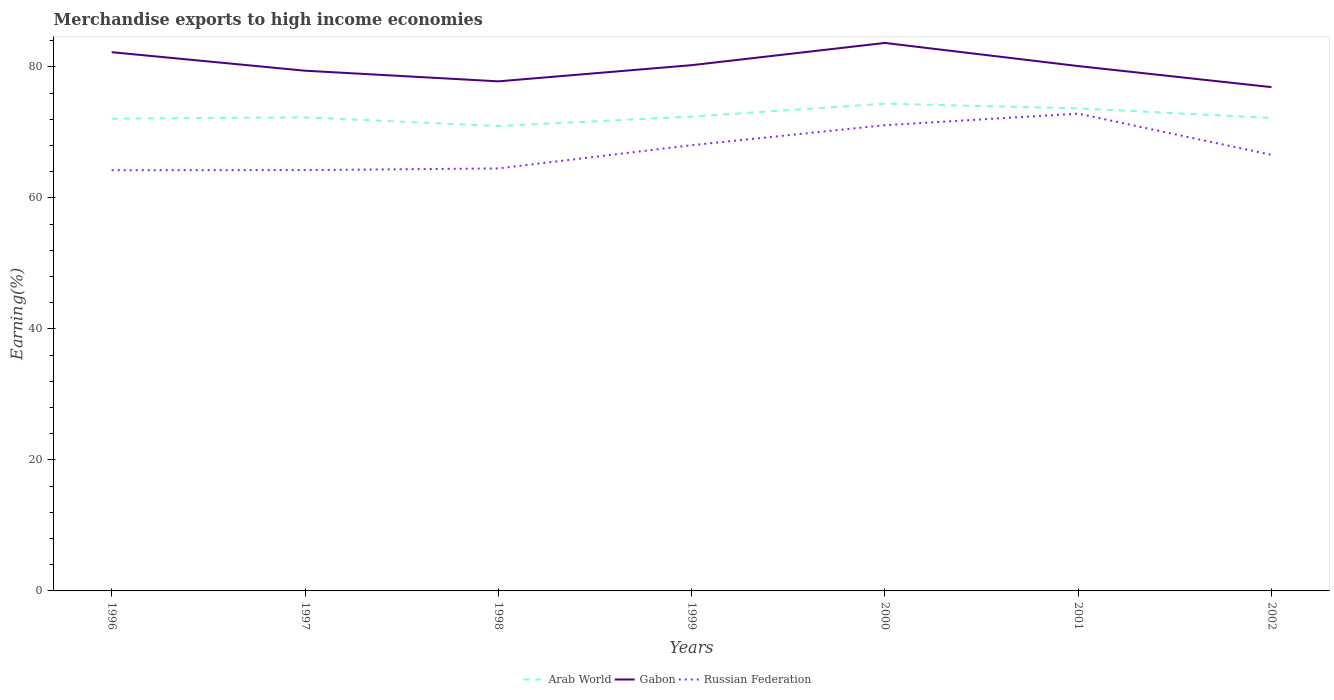How many different coloured lines are there?
Keep it short and to the point. 3. Does the line corresponding to Arab World intersect with the line corresponding to Gabon?
Provide a succinct answer. No. Across all years, what is the maximum percentage of amount earned from merchandise exports in Arab World?
Make the answer very short. 70.98. What is the total percentage of amount earned from merchandise exports in Russian Federation in the graph?
Your answer should be very brief. -3.55. What is the difference between the highest and the second highest percentage of amount earned from merchandise exports in Gabon?
Provide a succinct answer. 6.75. How many years are there in the graph?
Make the answer very short. 7. What is the difference between two consecutive major ticks on the Y-axis?
Ensure brevity in your answer.  20. Are the values on the major ticks of Y-axis written in scientific E-notation?
Make the answer very short. No. How many legend labels are there?
Ensure brevity in your answer.  3. How are the legend labels stacked?
Your answer should be very brief. Horizontal. What is the title of the graph?
Offer a terse response. Merchandise exports to high income economies. What is the label or title of the Y-axis?
Offer a terse response. Earning(%). What is the Earning(%) in Arab World in 1996?
Your answer should be very brief. 72.1. What is the Earning(%) of Gabon in 1996?
Your response must be concise. 82.25. What is the Earning(%) in Russian Federation in 1996?
Provide a succinct answer. 64.23. What is the Earning(%) in Arab World in 1997?
Your answer should be very brief. 72.3. What is the Earning(%) of Gabon in 1997?
Offer a very short reply. 79.42. What is the Earning(%) in Russian Federation in 1997?
Provide a short and direct response. 64.25. What is the Earning(%) of Arab World in 1998?
Provide a short and direct response. 70.98. What is the Earning(%) in Gabon in 1998?
Keep it short and to the point. 77.8. What is the Earning(%) in Russian Federation in 1998?
Offer a terse response. 64.5. What is the Earning(%) of Arab World in 1999?
Provide a short and direct response. 72.42. What is the Earning(%) in Gabon in 1999?
Offer a terse response. 80.27. What is the Earning(%) in Russian Federation in 1999?
Provide a succinct answer. 68.05. What is the Earning(%) in Arab World in 2000?
Keep it short and to the point. 74.39. What is the Earning(%) of Gabon in 2000?
Keep it short and to the point. 83.66. What is the Earning(%) of Russian Federation in 2000?
Keep it short and to the point. 71.11. What is the Earning(%) of Arab World in 2001?
Provide a succinct answer. 73.68. What is the Earning(%) in Gabon in 2001?
Give a very brief answer. 80.13. What is the Earning(%) in Russian Federation in 2001?
Ensure brevity in your answer.  72.87. What is the Earning(%) of Arab World in 2002?
Provide a short and direct response. 72.21. What is the Earning(%) of Gabon in 2002?
Give a very brief answer. 76.92. What is the Earning(%) of Russian Federation in 2002?
Offer a terse response. 66.58. Across all years, what is the maximum Earning(%) in Arab World?
Give a very brief answer. 74.39. Across all years, what is the maximum Earning(%) of Gabon?
Your answer should be compact. 83.66. Across all years, what is the maximum Earning(%) of Russian Federation?
Ensure brevity in your answer.  72.87. Across all years, what is the minimum Earning(%) of Arab World?
Make the answer very short. 70.98. Across all years, what is the minimum Earning(%) of Gabon?
Make the answer very short. 76.92. Across all years, what is the minimum Earning(%) of Russian Federation?
Provide a succinct answer. 64.23. What is the total Earning(%) of Arab World in the graph?
Your answer should be compact. 508.08. What is the total Earning(%) of Gabon in the graph?
Make the answer very short. 560.46. What is the total Earning(%) of Russian Federation in the graph?
Give a very brief answer. 471.6. What is the difference between the Earning(%) of Arab World in 1996 and that in 1997?
Provide a short and direct response. -0.2. What is the difference between the Earning(%) in Gabon in 1996 and that in 1997?
Your response must be concise. 2.83. What is the difference between the Earning(%) in Russian Federation in 1996 and that in 1997?
Offer a very short reply. -0.02. What is the difference between the Earning(%) of Arab World in 1996 and that in 1998?
Keep it short and to the point. 1.12. What is the difference between the Earning(%) in Gabon in 1996 and that in 1998?
Keep it short and to the point. 4.45. What is the difference between the Earning(%) of Russian Federation in 1996 and that in 1998?
Offer a terse response. -0.27. What is the difference between the Earning(%) of Arab World in 1996 and that in 1999?
Provide a succinct answer. -0.32. What is the difference between the Earning(%) of Gabon in 1996 and that in 1999?
Provide a succinct answer. 1.98. What is the difference between the Earning(%) in Russian Federation in 1996 and that in 1999?
Give a very brief answer. -3.82. What is the difference between the Earning(%) of Arab World in 1996 and that in 2000?
Keep it short and to the point. -2.29. What is the difference between the Earning(%) in Gabon in 1996 and that in 2000?
Ensure brevity in your answer.  -1.41. What is the difference between the Earning(%) in Russian Federation in 1996 and that in 2000?
Offer a very short reply. -6.87. What is the difference between the Earning(%) of Arab World in 1996 and that in 2001?
Your response must be concise. -1.57. What is the difference between the Earning(%) in Gabon in 1996 and that in 2001?
Give a very brief answer. 2.12. What is the difference between the Earning(%) of Russian Federation in 1996 and that in 2001?
Give a very brief answer. -8.64. What is the difference between the Earning(%) in Arab World in 1996 and that in 2002?
Your answer should be very brief. -0.11. What is the difference between the Earning(%) of Gabon in 1996 and that in 2002?
Give a very brief answer. 5.33. What is the difference between the Earning(%) of Russian Federation in 1996 and that in 2002?
Ensure brevity in your answer.  -2.34. What is the difference between the Earning(%) of Arab World in 1997 and that in 1998?
Your answer should be very brief. 1.32. What is the difference between the Earning(%) of Gabon in 1997 and that in 1998?
Provide a succinct answer. 1.62. What is the difference between the Earning(%) of Russian Federation in 1997 and that in 1998?
Make the answer very short. -0.25. What is the difference between the Earning(%) of Arab World in 1997 and that in 1999?
Offer a very short reply. -0.12. What is the difference between the Earning(%) in Gabon in 1997 and that in 1999?
Your answer should be compact. -0.84. What is the difference between the Earning(%) of Russian Federation in 1997 and that in 1999?
Ensure brevity in your answer.  -3.8. What is the difference between the Earning(%) of Arab World in 1997 and that in 2000?
Offer a terse response. -2.09. What is the difference between the Earning(%) in Gabon in 1997 and that in 2000?
Your answer should be very brief. -4.24. What is the difference between the Earning(%) in Russian Federation in 1997 and that in 2000?
Give a very brief answer. -6.86. What is the difference between the Earning(%) of Arab World in 1997 and that in 2001?
Make the answer very short. -1.38. What is the difference between the Earning(%) of Gabon in 1997 and that in 2001?
Offer a terse response. -0.71. What is the difference between the Earning(%) in Russian Federation in 1997 and that in 2001?
Your answer should be very brief. -8.62. What is the difference between the Earning(%) of Arab World in 1997 and that in 2002?
Ensure brevity in your answer.  0.09. What is the difference between the Earning(%) of Gabon in 1997 and that in 2002?
Make the answer very short. 2.51. What is the difference between the Earning(%) in Russian Federation in 1997 and that in 2002?
Your answer should be compact. -2.33. What is the difference between the Earning(%) of Arab World in 1998 and that in 1999?
Ensure brevity in your answer.  -1.44. What is the difference between the Earning(%) in Gabon in 1998 and that in 1999?
Ensure brevity in your answer.  -2.47. What is the difference between the Earning(%) of Russian Federation in 1998 and that in 1999?
Your answer should be very brief. -3.55. What is the difference between the Earning(%) of Arab World in 1998 and that in 2000?
Give a very brief answer. -3.41. What is the difference between the Earning(%) of Gabon in 1998 and that in 2000?
Offer a terse response. -5.86. What is the difference between the Earning(%) of Russian Federation in 1998 and that in 2000?
Give a very brief answer. -6.6. What is the difference between the Earning(%) in Arab World in 1998 and that in 2001?
Offer a terse response. -2.69. What is the difference between the Earning(%) of Gabon in 1998 and that in 2001?
Ensure brevity in your answer.  -2.33. What is the difference between the Earning(%) in Russian Federation in 1998 and that in 2001?
Offer a very short reply. -8.37. What is the difference between the Earning(%) of Arab World in 1998 and that in 2002?
Your answer should be compact. -1.23. What is the difference between the Earning(%) of Gabon in 1998 and that in 2002?
Your answer should be compact. 0.88. What is the difference between the Earning(%) in Russian Federation in 1998 and that in 2002?
Ensure brevity in your answer.  -2.07. What is the difference between the Earning(%) in Arab World in 1999 and that in 2000?
Give a very brief answer. -1.97. What is the difference between the Earning(%) of Gabon in 1999 and that in 2000?
Your answer should be very brief. -3.39. What is the difference between the Earning(%) of Russian Federation in 1999 and that in 2000?
Give a very brief answer. -3.05. What is the difference between the Earning(%) of Arab World in 1999 and that in 2001?
Ensure brevity in your answer.  -1.26. What is the difference between the Earning(%) of Gabon in 1999 and that in 2001?
Ensure brevity in your answer.  0.14. What is the difference between the Earning(%) in Russian Federation in 1999 and that in 2001?
Give a very brief answer. -4.82. What is the difference between the Earning(%) in Arab World in 1999 and that in 2002?
Provide a succinct answer. 0.21. What is the difference between the Earning(%) of Gabon in 1999 and that in 2002?
Provide a short and direct response. 3.35. What is the difference between the Earning(%) of Russian Federation in 1999 and that in 2002?
Ensure brevity in your answer.  1.48. What is the difference between the Earning(%) of Arab World in 2000 and that in 2001?
Provide a short and direct response. 0.72. What is the difference between the Earning(%) in Gabon in 2000 and that in 2001?
Offer a terse response. 3.53. What is the difference between the Earning(%) in Russian Federation in 2000 and that in 2001?
Make the answer very short. -1.76. What is the difference between the Earning(%) in Arab World in 2000 and that in 2002?
Your response must be concise. 2.18. What is the difference between the Earning(%) of Gabon in 2000 and that in 2002?
Keep it short and to the point. 6.75. What is the difference between the Earning(%) in Russian Federation in 2000 and that in 2002?
Offer a terse response. 4.53. What is the difference between the Earning(%) of Arab World in 2001 and that in 2002?
Make the answer very short. 1.47. What is the difference between the Earning(%) in Gabon in 2001 and that in 2002?
Offer a terse response. 3.22. What is the difference between the Earning(%) of Russian Federation in 2001 and that in 2002?
Your answer should be compact. 6.29. What is the difference between the Earning(%) in Arab World in 1996 and the Earning(%) in Gabon in 1997?
Offer a very short reply. -7.32. What is the difference between the Earning(%) in Arab World in 1996 and the Earning(%) in Russian Federation in 1997?
Offer a very short reply. 7.85. What is the difference between the Earning(%) in Gabon in 1996 and the Earning(%) in Russian Federation in 1997?
Give a very brief answer. 18. What is the difference between the Earning(%) of Arab World in 1996 and the Earning(%) of Gabon in 1998?
Your answer should be compact. -5.7. What is the difference between the Earning(%) in Arab World in 1996 and the Earning(%) in Russian Federation in 1998?
Make the answer very short. 7.6. What is the difference between the Earning(%) in Gabon in 1996 and the Earning(%) in Russian Federation in 1998?
Your response must be concise. 17.75. What is the difference between the Earning(%) in Arab World in 1996 and the Earning(%) in Gabon in 1999?
Offer a very short reply. -8.17. What is the difference between the Earning(%) in Arab World in 1996 and the Earning(%) in Russian Federation in 1999?
Ensure brevity in your answer.  4.05. What is the difference between the Earning(%) of Gabon in 1996 and the Earning(%) of Russian Federation in 1999?
Your answer should be very brief. 14.2. What is the difference between the Earning(%) of Arab World in 1996 and the Earning(%) of Gabon in 2000?
Make the answer very short. -11.56. What is the difference between the Earning(%) of Arab World in 1996 and the Earning(%) of Russian Federation in 2000?
Your response must be concise. 1. What is the difference between the Earning(%) of Gabon in 1996 and the Earning(%) of Russian Federation in 2000?
Give a very brief answer. 11.14. What is the difference between the Earning(%) of Arab World in 1996 and the Earning(%) of Gabon in 2001?
Make the answer very short. -8.03. What is the difference between the Earning(%) in Arab World in 1996 and the Earning(%) in Russian Federation in 2001?
Keep it short and to the point. -0.77. What is the difference between the Earning(%) in Gabon in 1996 and the Earning(%) in Russian Federation in 2001?
Your response must be concise. 9.38. What is the difference between the Earning(%) in Arab World in 1996 and the Earning(%) in Gabon in 2002?
Provide a short and direct response. -4.81. What is the difference between the Earning(%) of Arab World in 1996 and the Earning(%) of Russian Federation in 2002?
Offer a very short reply. 5.53. What is the difference between the Earning(%) in Gabon in 1996 and the Earning(%) in Russian Federation in 2002?
Make the answer very short. 15.67. What is the difference between the Earning(%) of Arab World in 1997 and the Earning(%) of Gabon in 1998?
Make the answer very short. -5.5. What is the difference between the Earning(%) of Arab World in 1997 and the Earning(%) of Russian Federation in 1998?
Your response must be concise. 7.8. What is the difference between the Earning(%) in Gabon in 1997 and the Earning(%) in Russian Federation in 1998?
Give a very brief answer. 14.92. What is the difference between the Earning(%) of Arab World in 1997 and the Earning(%) of Gabon in 1999?
Give a very brief answer. -7.97. What is the difference between the Earning(%) of Arab World in 1997 and the Earning(%) of Russian Federation in 1999?
Provide a succinct answer. 4.25. What is the difference between the Earning(%) of Gabon in 1997 and the Earning(%) of Russian Federation in 1999?
Make the answer very short. 11.37. What is the difference between the Earning(%) of Arab World in 1997 and the Earning(%) of Gabon in 2000?
Your answer should be compact. -11.36. What is the difference between the Earning(%) in Arab World in 1997 and the Earning(%) in Russian Federation in 2000?
Give a very brief answer. 1.19. What is the difference between the Earning(%) of Gabon in 1997 and the Earning(%) of Russian Federation in 2000?
Your answer should be compact. 8.32. What is the difference between the Earning(%) of Arab World in 1997 and the Earning(%) of Gabon in 2001?
Provide a short and direct response. -7.83. What is the difference between the Earning(%) in Arab World in 1997 and the Earning(%) in Russian Federation in 2001?
Provide a short and direct response. -0.57. What is the difference between the Earning(%) in Gabon in 1997 and the Earning(%) in Russian Federation in 2001?
Your response must be concise. 6.55. What is the difference between the Earning(%) in Arab World in 1997 and the Earning(%) in Gabon in 2002?
Keep it short and to the point. -4.62. What is the difference between the Earning(%) in Arab World in 1997 and the Earning(%) in Russian Federation in 2002?
Your answer should be compact. 5.72. What is the difference between the Earning(%) of Gabon in 1997 and the Earning(%) of Russian Federation in 2002?
Offer a terse response. 12.85. What is the difference between the Earning(%) in Arab World in 1998 and the Earning(%) in Gabon in 1999?
Ensure brevity in your answer.  -9.29. What is the difference between the Earning(%) in Arab World in 1998 and the Earning(%) in Russian Federation in 1999?
Provide a short and direct response. 2.93. What is the difference between the Earning(%) in Gabon in 1998 and the Earning(%) in Russian Federation in 1999?
Ensure brevity in your answer.  9.75. What is the difference between the Earning(%) of Arab World in 1998 and the Earning(%) of Gabon in 2000?
Keep it short and to the point. -12.68. What is the difference between the Earning(%) of Arab World in 1998 and the Earning(%) of Russian Federation in 2000?
Ensure brevity in your answer.  -0.12. What is the difference between the Earning(%) in Gabon in 1998 and the Earning(%) in Russian Federation in 2000?
Ensure brevity in your answer.  6.69. What is the difference between the Earning(%) in Arab World in 1998 and the Earning(%) in Gabon in 2001?
Offer a terse response. -9.15. What is the difference between the Earning(%) of Arab World in 1998 and the Earning(%) of Russian Federation in 2001?
Offer a very short reply. -1.89. What is the difference between the Earning(%) in Gabon in 1998 and the Earning(%) in Russian Federation in 2001?
Your response must be concise. 4.93. What is the difference between the Earning(%) of Arab World in 1998 and the Earning(%) of Gabon in 2002?
Your response must be concise. -5.93. What is the difference between the Earning(%) in Arab World in 1998 and the Earning(%) in Russian Federation in 2002?
Give a very brief answer. 4.41. What is the difference between the Earning(%) of Gabon in 1998 and the Earning(%) of Russian Federation in 2002?
Your response must be concise. 11.22. What is the difference between the Earning(%) in Arab World in 1999 and the Earning(%) in Gabon in 2000?
Make the answer very short. -11.24. What is the difference between the Earning(%) in Arab World in 1999 and the Earning(%) in Russian Federation in 2000?
Offer a terse response. 1.31. What is the difference between the Earning(%) in Gabon in 1999 and the Earning(%) in Russian Federation in 2000?
Offer a very short reply. 9.16. What is the difference between the Earning(%) of Arab World in 1999 and the Earning(%) of Gabon in 2001?
Make the answer very short. -7.71. What is the difference between the Earning(%) of Arab World in 1999 and the Earning(%) of Russian Federation in 2001?
Make the answer very short. -0.45. What is the difference between the Earning(%) of Gabon in 1999 and the Earning(%) of Russian Federation in 2001?
Your answer should be very brief. 7.4. What is the difference between the Earning(%) of Arab World in 1999 and the Earning(%) of Gabon in 2002?
Provide a succinct answer. -4.5. What is the difference between the Earning(%) in Arab World in 1999 and the Earning(%) in Russian Federation in 2002?
Make the answer very short. 5.84. What is the difference between the Earning(%) of Gabon in 1999 and the Earning(%) of Russian Federation in 2002?
Your answer should be compact. 13.69. What is the difference between the Earning(%) of Arab World in 2000 and the Earning(%) of Gabon in 2001?
Give a very brief answer. -5.74. What is the difference between the Earning(%) of Arab World in 2000 and the Earning(%) of Russian Federation in 2001?
Offer a very short reply. 1.52. What is the difference between the Earning(%) in Gabon in 2000 and the Earning(%) in Russian Federation in 2001?
Make the answer very short. 10.79. What is the difference between the Earning(%) of Arab World in 2000 and the Earning(%) of Gabon in 2002?
Your answer should be very brief. -2.52. What is the difference between the Earning(%) in Arab World in 2000 and the Earning(%) in Russian Federation in 2002?
Ensure brevity in your answer.  7.82. What is the difference between the Earning(%) of Gabon in 2000 and the Earning(%) of Russian Federation in 2002?
Offer a very short reply. 17.09. What is the difference between the Earning(%) of Arab World in 2001 and the Earning(%) of Gabon in 2002?
Keep it short and to the point. -3.24. What is the difference between the Earning(%) in Arab World in 2001 and the Earning(%) in Russian Federation in 2002?
Your answer should be compact. 7.1. What is the difference between the Earning(%) in Gabon in 2001 and the Earning(%) in Russian Federation in 2002?
Keep it short and to the point. 13.56. What is the average Earning(%) of Arab World per year?
Provide a succinct answer. 72.58. What is the average Earning(%) in Gabon per year?
Give a very brief answer. 80.07. What is the average Earning(%) of Russian Federation per year?
Offer a terse response. 67.37. In the year 1996, what is the difference between the Earning(%) of Arab World and Earning(%) of Gabon?
Keep it short and to the point. -10.15. In the year 1996, what is the difference between the Earning(%) of Arab World and Earning(%) of Russian Federation?
Offer a very short reply. 7.87. In the year 1996, what is the difference between the Earning(%) in Gabon and Earning(%) in Russian Federation?
Your answer should be very brief. 18.02. In the year 1997, what is the difference between the Earning(%) of Arab World and Earning(%) of Gabon?
Your answer should be compact. -7.12. In the year 1997, what is the difference between the Earning(%) in Arab World and Earning(%) in Russian Federation?
Make the answer very short. 8.05. In the year 1997, what is the difference between the Earning(%) of Gabon and Earning(%) of Russian Federation?
Offer a very short reply. 15.17. In the year 1998, what is the difference between the Earning(%) in Arab World and Earning(%) in Gabon?
Give a very brief answer. -6.82. In the year 1998, what is the difference between the Earning(%) of Arab World and Earning(%) of Russian Federation?
Your response must be concise. 6.48. In the year 1998, what is the difference between the Earning(%) in Gabon and Earning(%) in Russian Federation?
Your answer should be very brief. 13.3. In the year 1999, what is the difference between the Earning(%) of Arab World and Earning(%) of Gabon?
Make the answer very short. -7.85. In the year 1999, what is the difference between the Earning(%) of Arab World and Earning(%) of Russian Federation?
Your response must be concise. 4.37. In the year 1999, what is the difference between the Earning(%) of Gabon and Earning(%) of Russian Federation?
Your answer should be very brief. 12.22. In the year 2000, what is the difference between the Earning(%) in Arab World and Earning(%) in Gabon?
Your response must be concise. -9.27. In the year 2000, what is the difference between the Earning(%) in Arab World and Earning(%) in Russian Federation?
Offer a terse response. 3.29. In the year 2000, what is the difference between the Earning(%) in Gabon and Earning(%) in Russian Federation?
Provide a succinct answer. 12.56. In the year 2001, what is the difference between the Earning(%) of Arab World and Earning(%) of Gabon?
Offer a very short reply. -6.46. In the year 2001, what is the difference between the Earning(%) of Arab World and Earning(%) of Russian Federation?
Give a very brief answer. 0.81. In the year 2001, what is the difference between the Earning(%) of Gabon and Earning(%) of Russian Federation?
Provide a succinct answer. 7.26. In the year 2002, what is the difference between the Earning(%) in Arab World and Earning(%) in Gabon?
Offer a very short reply. -4.71. In the year 2002, what is the difference between the Earning(%) of Arab World and Earning(%) of Russian Federation?
Ensure brevity in your answer.  5.63. In the year 2002, what is the difference between the Earning(%) of Gabon and Earning(%) of Russian Federation?
Your response must be concise. 10.34. What is the ratio of the Earning(%) of Gabon in 1996 to that in 1997?
Your response must be concise. 1.04. What is the ratio of the Earning(%) in Arab World in 1996 to that in 1998?
Ensure brevity in your answer.  1.02. What is the ratio of the Earning(%) in Gabon in 1996 to that in 1998?
Provide a succinct answer. 1.06. What is the ratio of the Earning(%) in Gabon in 1996 to that in 1999?
Make the answer very short. 1.02. What is the ratio of the Earning(%) in Russian Federation in 1996 to that in 1999?
Offer a very short reply. 0.94. What is the ratio of the Earning(%) in Arab World in 1996 to that in 2000?
Provide a succinct answer. 0.97. What is the ratio of the Earning(%) of Gabon in 1996 to that in 2000?
Your answer should be very brief. 0.98. What is the ratio of the Earning(%) in Russian Federation in 1996 to that in 2000?
Offer a terse response. 0.9. What is the ratio of the Earning(%) of Arab World in 1996 to that in 2001?
Keep it short and to the point. 0.98. What is the ratio of the Earning(%) in Gabon in 1996 to that in 2001?
Offer a terse response. 1.03. What is the ratio of the Earning(%) of Russian Federation in 1996 to that in 2001?
Make the answer very short. 0.88. What is the ratio of the Earning(%) in Gabon in 1996 to that in 2002?
Your answer should be very brief. 1.07. What is the ratio of the Earning(%) in Russian Federation in 1996 to that in 2002?
Give a very brief answer. 0.96. What is the ratio of the Earning(%) in Arab World in 1997 to that in 1998?
Your response must be concise. 1.02. What is the ratio of the Earning(%) in Gabon in 1997 to that in 1998?
Keep it short and to the point. 1.02. What is the ratio of the Earning(%) of Gabon in 1997 to that in 1999?
Offer a terse response. 0.99. What is the ratio of the Earning(%) of Russian Federation in 1997 to that in 1999?
Your answer should be very brief. 0.94. What is the ratio of the Earning(%) of Arab World in 1997 to that in 2000?
Give a very brief answer. 0.97. What is the ratio of the Earning(%) in Gabon in 1997 to that in 2000?
Ensure brevity in your answer.  0.95. What is the ratio of the Earning(%) of Russian Federation in 1997 to that in 2000?
Your answer should be compact. 0.9. What is the ratio of the Earning(%) in Arab World in 1997 to that in 2001?
Your answer should be compact. 0.98. What is the ratio of the Earning(%) of Gabon in 1997 to that in 2001?
Provide a succinct answer. 0.99. What is the ratio of the Earning(%) in Russian Federation in 1997 to that in 2001?
Ensure brevity in your answer.  0.88. What is the ratio of the Earning(%) in Gabon in 1997 to that in 2002?
Give a very brief answer. 1.03. What is the ratio of the Earning(%) in Russian Federation in 1997 to that in 2002?
Your answer should be compact. 0.97. What is the ratio of the Earning(%) of Arab World in 1998 to that in 1999?
Provide a short and direct response. 0.98. What is the ratio of the Earning(%) of Gabon in 1998 to that in 1999?
Make the answer very short. 0.97. What is the ratio of the Earning(%) in Russian Federation in 1998 to that in 1999?
Provide a succinct answer. 0.95. What is the ratio of the Earning(%) in Arab World in 1998 to that in 2000?
Provide a succinct answer. 0.95. What is the ratio of the Earning(%) of Gabon in 1998 to that in 2000?
Keep it short and to the point. 0.93. What is the ratio of the Earning(%) of Russian Federation in 1998 to that in 2000?
Offer a very short reply. 0.91. What is the ratio of the Earning(%) in Arab World in 1998 to that in 2001?
Your response must be concise. 0.96. What is the ratio of the Earning(%) in Gabon in 1998 to that in 2001?
Give a very brief answer. 0.97. What is the ratio of the Earning(%) of Russian Federation in 1998 to that in 2001?
Your response must be concise. 0.89. What is the ratio of the Earning(%) of Gabon in 1998 to that in 2002?
Give a very brief answer. 1.01. What is the ratio of the Earning(%) in Russian Federation in 1998 to that in 2002?
Offer a very short reply. 0.97. What is the ratio of the Earning(%) of Arab World in 1999 to that in 2000?
Give a very brief answer. 0.97. What is the ratio of the Earning(%) in Gabon in 1999 to that in 2000?
Provide a short and direct response. 0.96. What is the ratio of the Earning(%) in Russian Federation in 1999 to that in 2000?
Your answer should be very brief. 0.96. What is the ratio of the Earning(%) of Arab World in 1999 to that in 2001?
Your answer should be compact. 0.98. What is the ratio of the Earning(%) in Russian Federation in 1999 to that in 2001?
Ensure brevity in your answer.  0.93. What is the ratio of the Earning(%) in Arab World in 1999 to that in 2002?
Give a very brief answer. 1. What is the ratio of the Earning(%) in Gabon in 1999 to that in 2002?
Provide a succinct answer. 1.04. What is the ratio of the Earning(%) in Russian Federation in 1999 to that in 2002?
Provide a succinct answer. 1.02. What is the ratio of the Earning(%) in Arab World in 2000 to that in 2001?
Keep it short and to the point. 1.01. What is the ratio of the Earning(%) in Gabon in 2000 to that in 2001?
Your response must be concise. 1.04. What is the ratio of the Earning(%) of Russian Federation in 2000 to that in 2001?
Ensure brevity in your answer.  0.98. What is the ratio of the Earning(%) in Arab World in 2000 to that in 2002?
Give a very brief answer. 1.03. What is the ratio of the Earning(%) in Gabon in 2000 to that in 2002?
Your answer should be compact. 1.09. What is the ratio of the Earning(%) of Russian Federation in 2000 to that in 2002?
Provide a short and direct response. 1.07. What is the ratio of the Earning(%) in Arab World in 2001 to that in 2002?
Provide a succinct answer. 1.02. What is the ratio of the Earning(%) in Gabon in 2001 to that in 2002?
Provide a short and direct response. 1.04. What is the ratio of the Earning(%) of Russian Federation in 2001 to that in 2002?
Your answer should be compact. 1.09. What is the difference between the highest and the second highest Earning(%) of Arab World?
Provide a short and direct response. 0.72. What is the difference between the highest and the second highest Earning(%) of Gabon?
Your answer should be very brief. 1.41. What is the difference between the highest and the second highest Earning(%) of Russian Federation?
Ensure brevity in your answer.  1.76. What is the difference between the highest and the lowest Earning(%) in Arab World?
Your answer should be very brief. 3.41. What is the difference between the highest and the lowest Earning(%) of Gabon?
Make the answer very short. 6.75. What is the difference between the highest and the lowest Earning(%) of Russian Federation?
Offer a very short reply. 8.64. 